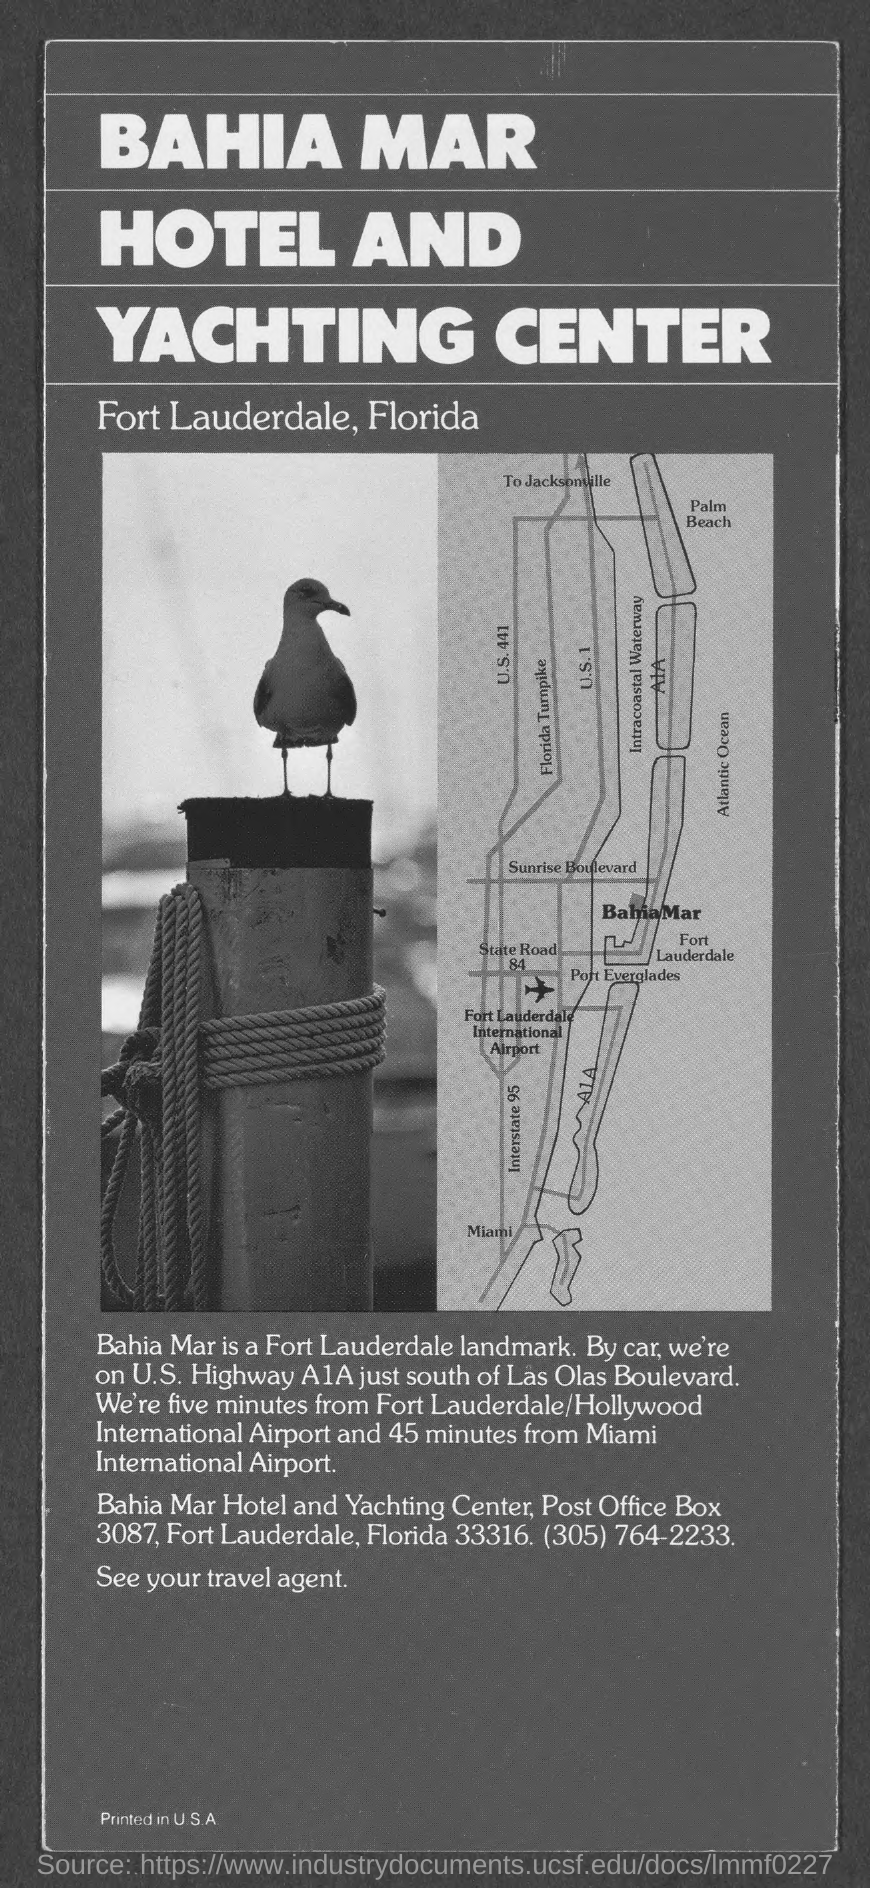Specify some key components in this picture. It is located south of LAS OLAS BOULEVARD. The distance from Miami International Airport is approximately 45 minutes. Fort Lauderdale/Hollywood International Airport is located approximately five minutes away. 